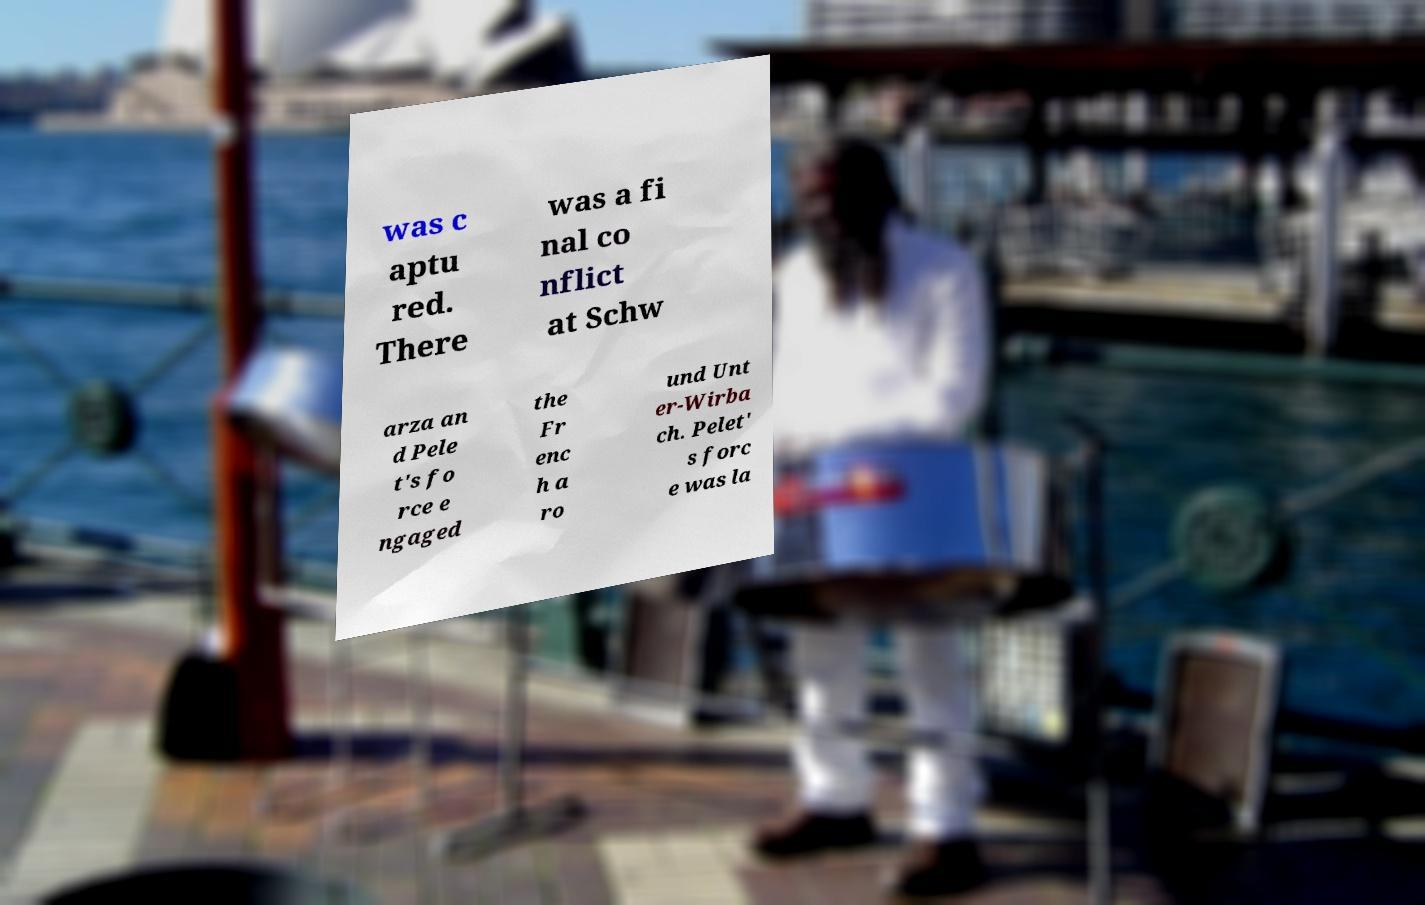I need the written content from this picture converted into text. Can you do that? was c aptu red. There was a fi nal co nflict at Schw arza an d Pele t's fo rce e ngaged the Fr enc h a ro und Unt er-Wirba ch. Pelet' s forc e was la 